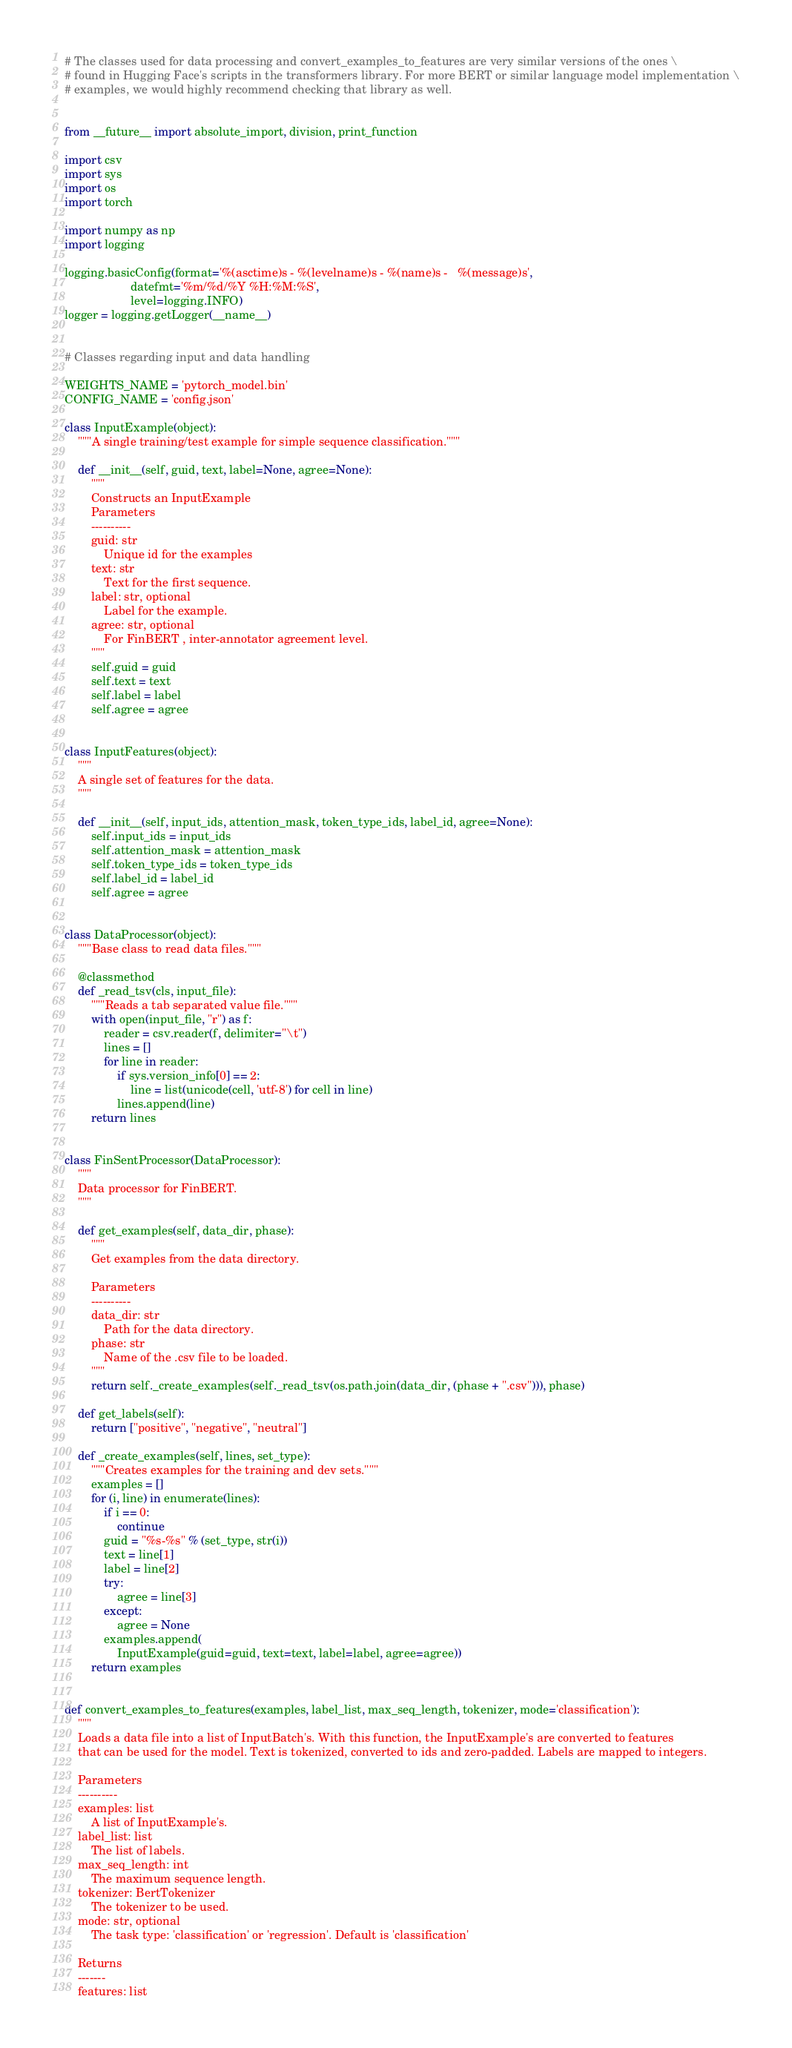Convert code to text. <code><loc_0><loc_0><loc_500><loc_500><_Python_># The classes used for data processing and convert_examples_to_features are very similar versions of the ones \
# found in Hugging Face's scripts in the transformers library. For more BERT or similar language model implementation \
# examples, we would highly recommend checking that library as well.


from __future__ import absolute_import, division, print_function

import csv
import sys
import os
import torch

import numpy as np
import logging

logging.basicConfig(format='%(asctime)s - %(levelname)s - %(name)s -   %(message)s',
                    datefmt='%m/%d/%Y %H:%M:%S',
                    level=logging.INFO)
logger = logging.getLogger(__name__)


# Classes regarding input and data handling

WEIGHTS_NAME = 'pytorch_model.bin'
CONFIG_NAME = 'config.json'

class InputExample(object):
    """A single training/test example for simple sequence classification."""

    def __init__(self, guid, text, label=None, agree=None):
        """
        Constructs an InputExample
        Parameters
        ----------
        guid: str
            Unique id for the examples
        text: str
            Text for the first sequence.
        label: str, optional
            Label for the example.
        agree: str, optional
            For FinBERT , inter-annotator agreement level.
        """
        self.guid = guid
        self.text = text
        self.label = label
        self.agree = agree


class InputFeatures(object):
    """
    A single set of features for the data.
    """

    def __init__(self, input_ids, attention_mask, token_type_ids, label_id, agree=None):
        self.input_ids = input_ids
        self.attention_mask = attention_mask
        self.token_type_ids = token_type_ids
        self.label_id = label_id
        self.agree = agree


class DataProcessor(object):
    """Base class to read data files."""

    @classmethod
    def _read_tsv(cls, input_file):
        """Reads a tab separated value file."""
        with open(input_file, "r") as f:
            reader = csv.reader(f, delimiter="\t")
            lines = []
            for line in reader:
                if sys.version_info[0] == 2:
                    line = list(unicode(cell, 'utf-8') for cell in line)
                lines.append(line)
        return lines


class FinSentProcessor(DataProcessor):
    """
    Data processor for FinBERT.
    """

    def get_examples(self, data_dir, phase):
        """
        Get examples from the data directory.

        Parameters
        ----------
        data_dir: str
            Path for the data directory.
        phase: str
            Name of the .csv file to be loaded.
        """
        return self._create_examples(self._read_tsv(os.path.join(data_dir, (phase + ".csv"))), phase)

    def get_labels(self):
        return ["positive", "negative", "neutral"]

    def _create_examples(self, lines, set_type):
        """Creates examples for the training and dev sets."""
        examples = []
        for (i, line) in enumerate(lines):
            if i == 0:
                continue
            guid = "%s-%s" % (set_type, str(i))
            text = line[1]
            label = line[2]
            try:
                agree = line[3]
            except:
                agree = None
            examples.append(
                InputExample(guid=guid, text=text, label=label, agree=agree))
        return examples


def convert_examples_to_features(examples, label_list, max_seq_length, tokenizer, mode='classification'):
    """
    Loads a data file into a list of InputBatch's. With this function, the InputExample's are converted to features
    that can be used for the model. Text is tokenized, converted to ids and zero-padded. Labels are mapped to integers.

    Parameters
    ----------
    examples: list
        A list of InputExample's.
    label_list: list
        The list of labels.
    max_seq_length: int
        The maximum sequence length.
    tokenizer: BertTokenizer
        The tokenizer to be used.
    mode: str, optional
        The task type: 'classification' or 'regression'. Default is 'classification'

    Returns
    -------
    features: list</code> 